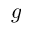<formula> <loc_0><loc_0><loc_500><loc_500>g</formula> 